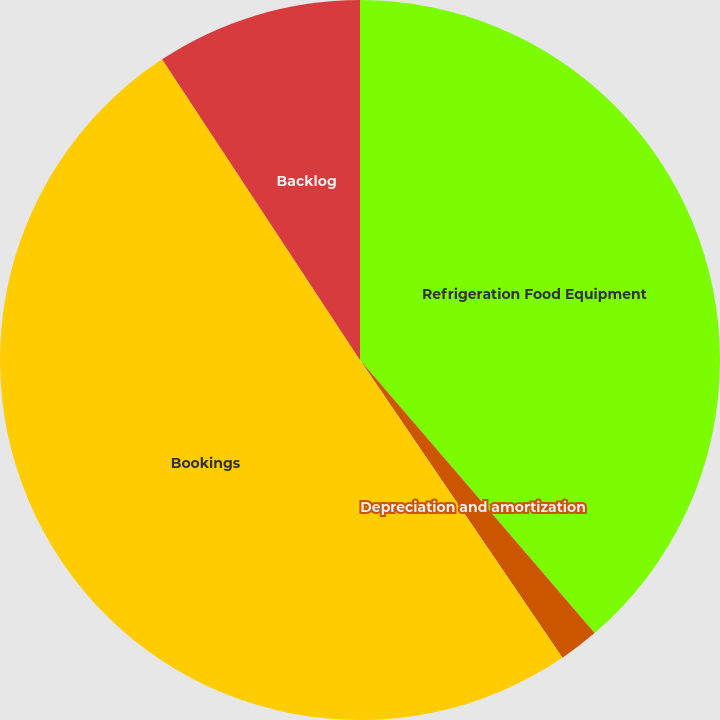Convert chart. <chart><loc_0><loc_0><loc_500><loc_500><pie_chart><fcel>Refrigeration Food Equipment<fcel>Depreciation and amortization<fcel>Bookings<fcel>Backlog<nl><fcel>38.7%<fcel>1.79%<fcel>50.24%<fcel>9.26%<nl></chart> 